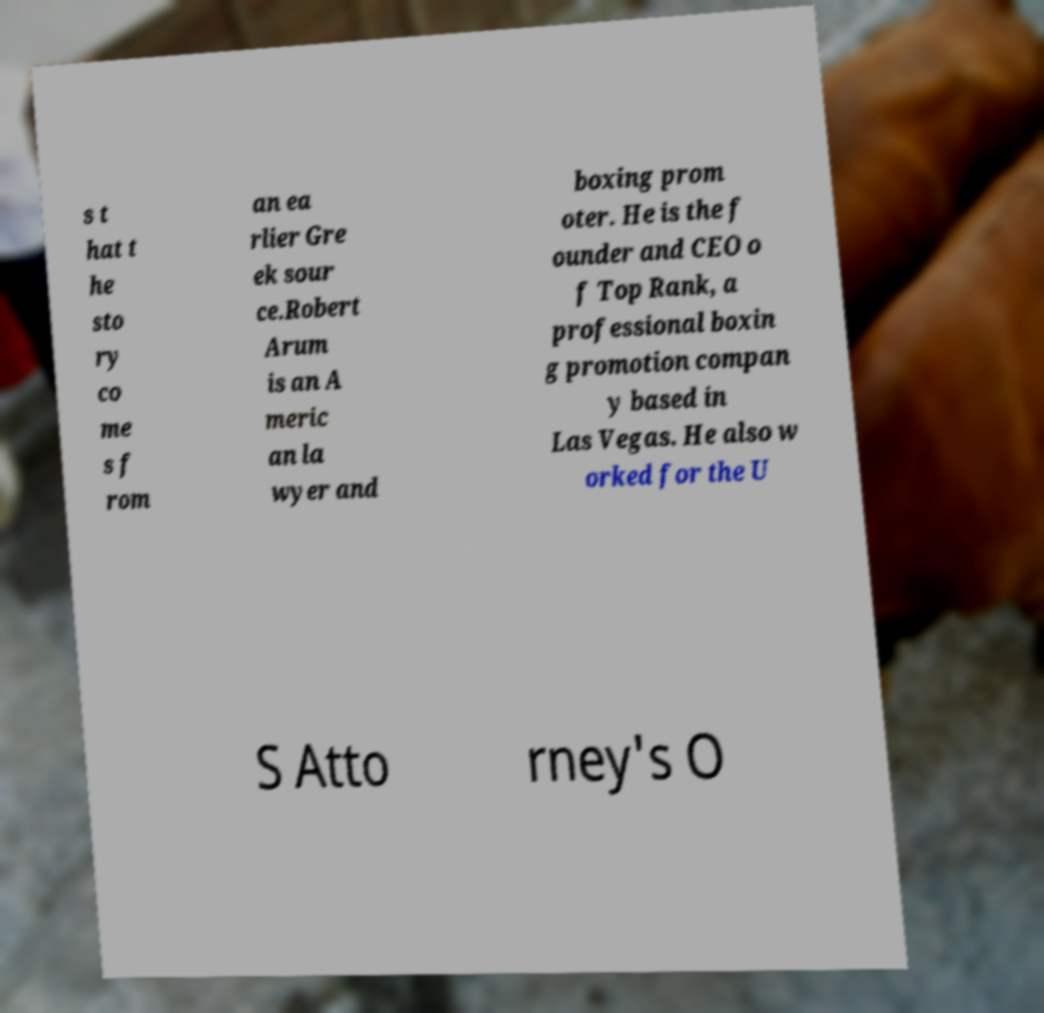There's text embedded in this image that I need extracted. Can you transcribe it verbatim? s t hat t he sto ry co me s f rom an ea rlier Gre ek sour ce.Robert Arum is an A meric an la wyer and boxing prom oter. He is the f ounder and CEO o f Top Rank, a professional boxin g promotion compan y based in Las Vegas. He also w orked for the U S Atto rney's O 